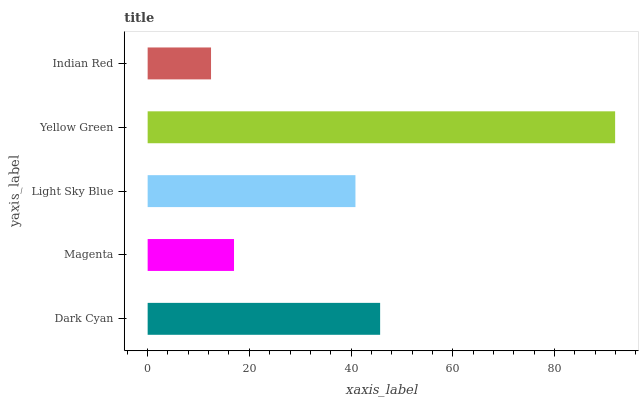Is Indian Red the minimum?
Answer yes or no. Yes. Is Yellow Green the maximum?
Answer yes or no. Yes. Is Magenta the minimum?
Answer yes or no. No. Is Magenta the maximum?
Answer yes or no. No. Is Dark Cyan greater than Magenta?
Answer yes or no. Yes. Is Magenta less than Dark Cyan?
Answer yes or no. Yes. Is Magenta greater than Dark Cyan?
Answer yes or no. No. Is Dark Cyan less than Magenta?
Answer yes or no. No. Is Light Sky Blue the high median?
Answer yes or no. Yes. Is Light Sky Blue the low median?
Answer yes or no. Yes. Is Magenta the high median?
Answer yes or no. No. Is Yellow Green the low median?
Answer yes or no. No. 